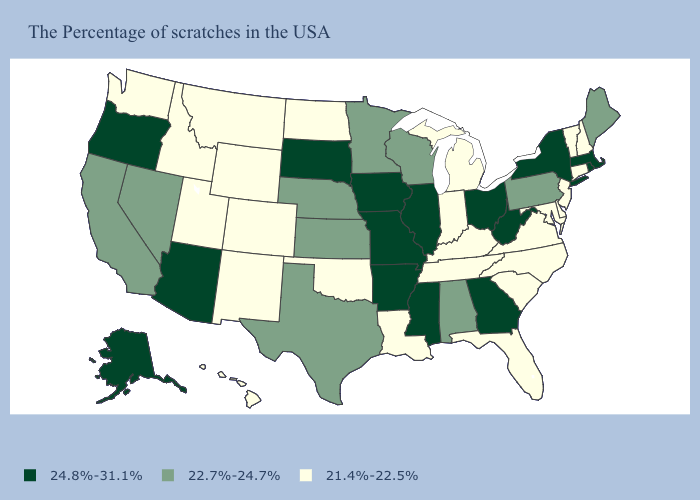What is the value of Wisconsin?
Short answer required. 22.7%-24.7%. What is the highest value in the Northeast ?
Be succinct. 24.8%-31.1%. Name the states that have a value in the range 21.4%-22.5%?
Quick response, please. New Hampshire, Vermont, Connecticut, New Jersey, Delaware, Maryland, Virginia, North Carolina, South Carolina, Florida, Michigan, Kentucky, Indiana, Tennessee, Louisiana, Oklahoma, North Dakota, Wyoming, Colorado, New Mexico, Utah, Montana, Idaho, Washington, Hawaii. Name the states that have a value in the range 21.4%-22.5%?
Answer briefly. New Hampshire, Vermont, Connecticut, New Jersey, Delaware, Maryland, Virginia, North Carolina, South Carolina, Florida, Michigan, Kentucky, Indiana, Tennessee, Louisiana, Oklahoma, North Dakota, Wyoming, Colorado, New Mexico, Utah, Montana, Idaho, Washington, Hawaii. What is the value of Missouri?
Answer briefly. 24.8%-31.1%. Which states have the highest value in the USA?
Answer briefly. Massachusetts, Rhode Island, New York, West Virginia, Ohio, Georgia, Illinois, Mississippi, Missouri, Arkansas, Iowa, South Dakota, Arizona, Oregon, Alaska. What is the value of Alaska?
Concise answer only. 24.8%-31.1%. Which states have the lowest value in the USA?
Keep it brief. New Hampshire, Vermont, Connecticut, New Jersey, Delaware, Maryland, Virginia, North Carolina, South Carolina, Florida, Michigan, Kentucky, Indiana, Tennessee, Louisiana, Oklahoma, North Dakota, Wyoming, Colorado, New Mexico, Utah, Montana, Idaho, Washington, Hawaii. Name the states that have a value in the range 22.7%-24.7%?
Keep it brief. Maine, Pennsylvania, Alabama, Wisconsin, Minnesota, Kansas, Nebraska, Texas, Nevada, California. What is the value of California?
Answer briefly. 22.7%-24.7%. Among the states that border Wyoming , does South Dakota have the highest value?
Give a very brief answer. Yes. What is the highest value in the West ?
Short answer required. 24.8%-31.1%. What is the lowest value in the South?
Short answer required. 21.4%-22.5%. Does New Mexico have the lowest value in the USA?
Write a very short answer. Yes. 